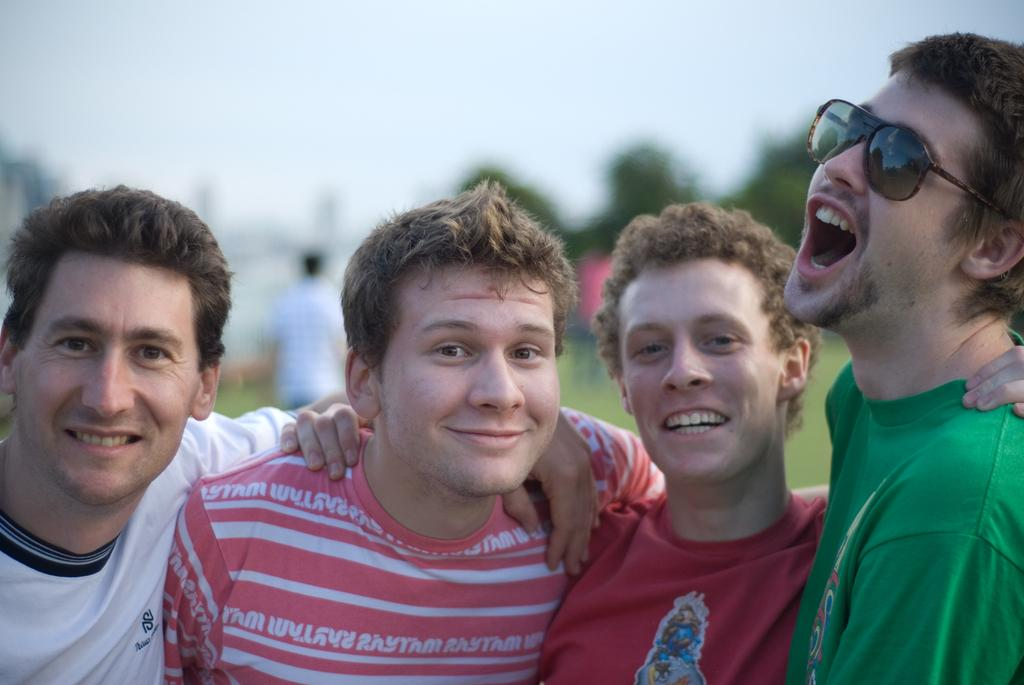What is happening with the group of people in the image? The people in the image are standing and smiling. Can you describe the people in the background of the image? There are other people visible in the background of the image. What can be seen in the background besides the people? Trees are present in the background of the image. How many kittens are sitting on the carriage in the image? There is no carriage or kittens present in the image. 